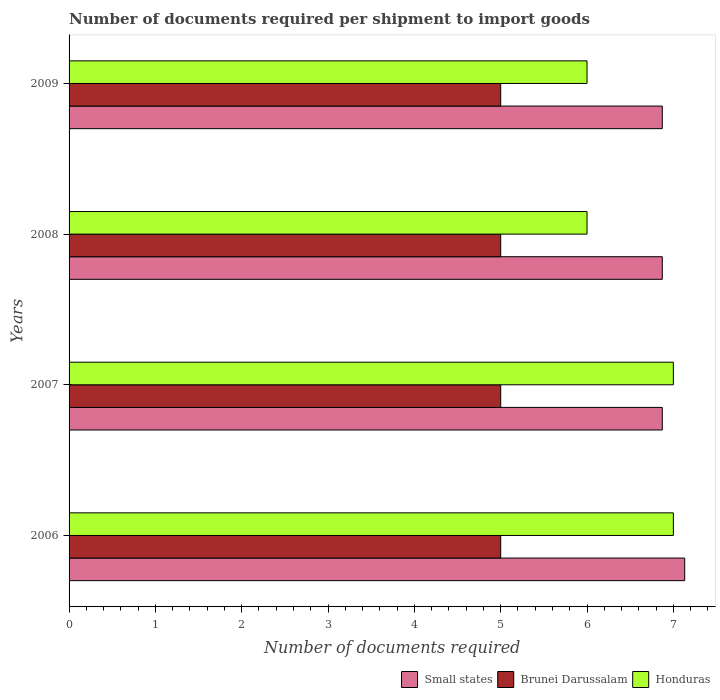Across all years, what is the maximum number of documents required per shipment to import goods in Honduras?
Keep it short and to the point. 7. Across all years, what is the minimum number of documents required per shipment to import goods in Small states?
Ensure brevity in your answer.  6.87. In which year was the number of documents required per shipment to import goods in Brunei Darussalam minimum?
Your response must be concise. 2006. What is the total number of documents required per shipment to import goods in Small states in the graph?
Offer a terse response. 27.75. What is the difference between the number of documents required per shipment to import goods in Small states in 2006 and that in 2008?
Ensure brevity in your answer.  0.26. What is the difference between the number of documents required per shipment to import goods in Honduras in 2009 and the number of documents required per shipment to import goods in Small states in 2008?
Keep it short and to the point. -0.87. What is the average number of documents required per shipment to import goods in Small states per year?
Make the answer very short. 6.94. In how many years, is the number of documents required per shipment to import goods in Honduras greater than 2.4 ?
Offer a very short reply. 4. What is the ratio of the number of documents required per shipment to import goods in Brunei Darussalam in 2006 to that in 2007?
Offer a terse response. 1. Is the difference between the number of documents required per shipment to import goods in Honduras in 2008 and 2009 greater than the difference between the number of documents required per shipment to import goods in Brunei Darussalam in 2008 and 2009?
Your answer should be compact. No. What is the difference between the highest and the second highest number of documents required per shipment to import goods in Brunei Darussalam?
Your answer should be very brief. 0. What is the difference between the highest and the lowest number of documents required per shipment to import goods in Small states?
Offer a terse response. 0.26. In how many years, is the number of documents required per shipment to import goods in Honduras greater than the average number of documents required per shipment to import goods in Honduras taken over all years?
Keep it short and to the point. 2. Is the sum of the number of documents required per shipment to import goods in Honduras in 2006 and 2009 greater than the maximum number of documents required per shipment to import goods in Brunei Darussalam across all years?
Offer a very short reply. Yes. What does the 2nd bar from the top in 2007 represents?
Offer a terse response. Brunei Darussalam. What does the 3rd bar from the bottom in 2007 represents?
Give a very brief answer. Honduras. How many bars are there?
Your answer should be compact. 12. What is the difference between two consecutive major ticks on the X-axis?
Give a very brief answer. 1. Are the values on the major ticks of X-axis written in scientific E-notation?
Keep it short and to the point. No. Does the graph contain any zero values?
Offer a very short reply. No. Does the graph contain grids?
Provide a succinct answer. No. Where does the legend appear in the graph?
Offer a terse response. Bottom right. How many legend labels are there?
Offer a very short reply. 3. How are the legend labels stacked?
Give a very brief answer. Horizontal. What is the title of the graph?
Keep it short and to the point. Number of documents required per shipment to import goods. What is the label or title of the X-axis?
Make the answer very short. Number of documents required. What is the label or title of the Y-axis?
Provide a short and direct response. Years. What is the Number of documents required of Small states in 2006?
Your response must be concise. 7.13. What is the Number of documents required in Small states in 2007?
Make the answer very short. 6.87. What is the Number of documents required in Small states in 2008?
Your response must be concise. 6.87. What is the Number of documents required in Small states in 2009?
Provide a succinct answer. 6.87. What is the Number of documents required of Brunei Darussalam in 2009?
Your response must be concise. 5. Across all years, what is the maximum Number of documents required of Small states?
Keep it short and to the point. 7.13. Across all years, what is the minimum Number of documents required of Small states?
Provide a succinct answer. 6.87. Across all years, what is the minimum Number of documents required of Brunei Darussalam?
Provide a short and direct response. 5. What is the total Number of documents required of Small states in the graph?
Your answer should be very brief. 27.75. What is the total Number of documents required of Brunei Darussalam in the graph?
Your answer should be very brief. 20. What is the difference between the Number of documents required in Small states in 2006 and that in 2007?
Provide a succinct answer. 0.26. What is the difference between the Number of documents required in Brunei Darussalam in 2006 and that in 2007?
Give a very brief answer. 0. What is the difference between the Number of documents required in Small states in 2006 and that in 2008?
Offer a terse response. 0.26. What is the difference between the Number of documents required in Brunei Darussalam in 2006 and that in 2008?
Keep it short and to the point. 0. What is the difference between the Number of documents required in Small states in 2006 and that in 2009?
Make the answer very short. 0.26. What is the difference between the Number of documents required of Honduras in 2006 and that in 2009?
Your answer should be very brief. 1. What is the difference between the Number of documents required of Small states in 2007 and that in 2008?
Ensure brevity in your answer.  0. What is the difference between the Number of documents required in Brunei Darussalam in 2007 and that in 2008?
Offer a very short reply. 0. What is the difference between the Number of documents required of Brunei Darussalam in 2008 and that in 2009?
Make the answer very short. 0. What is the difference between the Number of documents required of Honduras in 2008 and that in 2009?
Your answer should be compact. 0. What is the difference between the Number of documents required of Small states in 2006 and the Number of documents required of Brunei Darussalam in 2007?
Provide a succinct answer. 2.13. What is the difference between the Number of documents required in Small states in 2006 and the Number of documents required in Honduras in 2007?
Your answer should be very brief. 0.13. What is the difference between the Number of documents required in Small states in 2006 and the Number of documents required in Brunei Darussalam in 2008?
Provide a succinct answer. 2.13. What is the difference between the Number of documents required in Small states in 2006 and the Number of documents required in Honduras in 2008?
Your response must be concise. 1.13. What is the difference between the Number of documents required of Brunei Darussalam in 2006 and the Number of documents required of Honduras in 2008?
Your response must be concise. -1. What is the difference between the Number of documents required of Small states in 2006 and the Number of documents required of Brunei Darussalam in 2009?
Provide a succinct answer. 2.13. What is the difference between the Number of documents required of Small states in 2006 and the Number of documents required of Honduras in 2009?
Your answer should be compact. 1.13. What is the difference between the Number of documents required of Brunei Darussalam in 2006 and the Number of documents required of Honduras in 2009?
Provide a short and direct response. -1. What is the difference between the Number of documents required of Small states in 2007 and the Number of documents required of Brunei Darussalam in 2008?
Give a very brief answer. 1.87. What is the difference between the Number of documents required of Small states in 2007 and the Number of documents required of Honduras in 2008?
Keep it short and to the point. 0.87. What is the difference between the Number of documents required of Brunei Darussalam in 2007 and the Number of documents required of Honduras in 2008?
Provide a succinct answer. -1. What is the difference between the Number of documents required of Small states in 2007 and the Number of documents required of Brunei Darussalam in 2009?
Provide a succinct answer. 1.87. What is the difference between the Number of documents required in Small states in 2007 and the Number of documents required in Honduras in 2009?
Give a very brief answer. 0.87. What is the difference between the Number of documents required of Brunei Darussalam in 2007 and the Number of documents required of Honduras in 2009?
Make the answer very short. -1. What is the difference between the Number of documents required in Small states in 2008 and the Number of documents required in Brunei Darussalam in 2009?
Keep it short and to the point. 1.87. What is the difference between the Number of documents required in Small states in 2008 and the Number of documents required in Honduras in 2009?
Offer a very short reply. 0.87. What is the difference between the Number of documents required of Brunei Darussalam in 2008 and the Number of documents required of Honduras in 2009?
Give a very brief answer. -1. What is the average Number of documents required in Small states per year?
Ensure brevity in your answer.  6.94. What is the average Number of documents required in Honduras per year?
Offer a very short reply. 6.5. In the year 2006, what is the difference between the Number of documents required of Small states and Number of documents required of Brunei Darussalam?
Ensure brevity in your answer.  2.13. In the year 2006, what is the difference between the Number of documents required in Small states and Number of documents required in Honduras?
Provide a succinct answer. 0.13. In the year 2006, what is the difference between the Number of documents required in Brunei Darussalam and Number of documents required in Honduras?
Ensure brevity in your answer.  -2. In the year 2007, what is the difference between the Number of documents required in Small states and Number of documents required in Brunei Darussalam?
Provide a short and direct response. 1.87. In the year 2007, what is the difference between the Number of documents required of Small states and Number of documents required of Honduras?
Offer a terse response. -0.13. In the year 2008, what is the difference between the Number of documents required of Small states and Number of documents required of Brunei Darussalam?
Provide a short and direct response. 1.87. In the year 2008, what is the difference between the Number of documents required in Small states and Number of documents required in Honduras?
Offer a terse response. 0.87. In the year 2009, what is the difference between the Number of documents required of Small states and Number of documents required of Brunei Darussalam?
Provide a short and direct response. 1.87. In the year 2009, what is the difference between the Number of documents required of Small states and Number of documents required of Honduras?
Your answer should be compact. 0.87. In the year 2009, what is the difference between the Number of documents required in Brunei Darussalam and Number of documents required in Honduras?
Provide a short and direct response. -1. What is the ratio of the Number of documents required of Small states in 2006 to that in 2007?
Offer a very short reply. 1.04. What is the ratio of the Number of documents required of Small states in 2006 to that in 2008?
Offer a very short reply. 1.04. What is the ratio of the Number of documents required in Small states in 2006 to that in 2009?
Provide a succinct answer. 1.04. What is the ratio of the Number of documents required of Brunei Darussalam in 2006 to that in 2009?
Offer a terse response. 1. What is the ratio of the Number of documents required in Brunei Darussalam in 2007 to that in 2009?
Your answer should be compact. 1. What is the ratio of the Number of documents required in Small states in 2008 to that in 2009?
Keep it short and to the point. 1. What is the ratio of the Number of documents required in Brunei Darussalam in 2008 to that in 2009?
Provide a succinct answer. 1. What is the difference between the highest and the second highest Number of documents required of Small states?
Give a very brief answer. 0.26. What is the difference between the highest and the second highest Number of documents required of Brunei Darussalam?
Provide a succinct answer. 0. What is the difference between the highest and the second highest Number of documents required of Honduras?
Your response must be concise. 0. What is the difference between the highest and the lowest Number of documents required in Small states?
Your answer should be very brief. 0.26. 